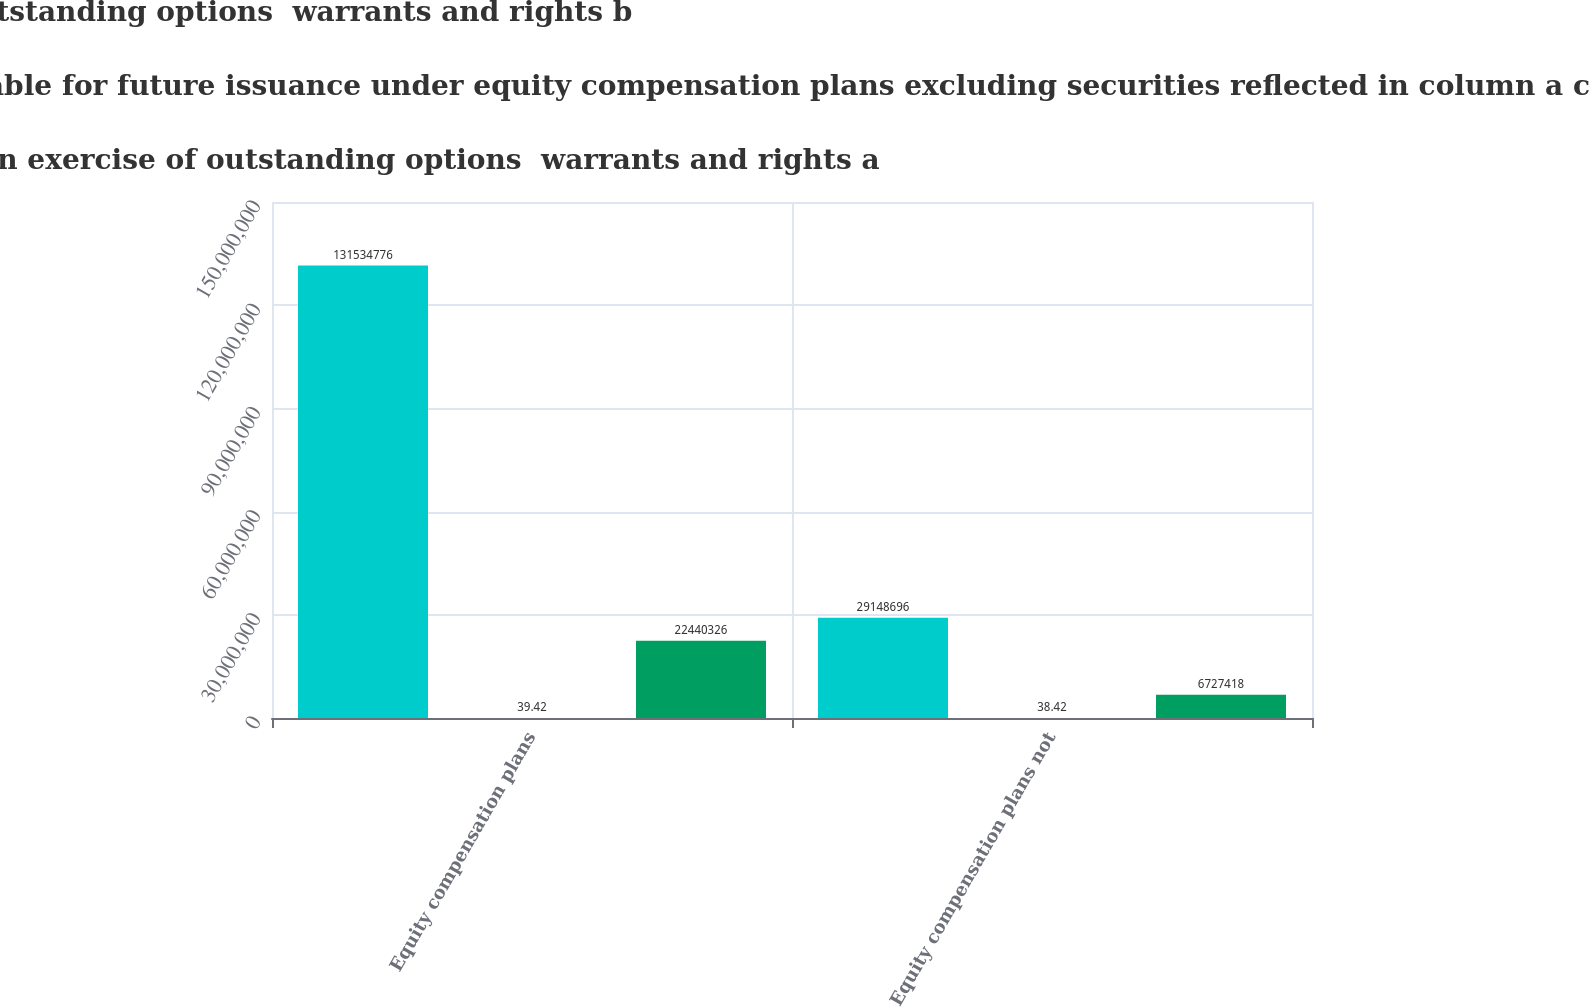<chart> <loc_0><loc_0><loc_500><loc_500><stacked_bar_chart><ecel><fcel>Equity compensation plans<fcel>Equity compensation plans not<nl><fcel>Weighted average exercise price of outstanding options  warrants and rights b<fcel>1.31535e+08<fcel>2.91487e+07<nl><fcel>Number of securities remaining available for future issuance under equity compensation plans excluding securities reflected in column a c<fcel>39.42<fcel>38.42<nl><fcel>Number of securities to be issued upon exercise of outstanding options  warrants and rights a<fcel>2.24403e+07<fcel>6.72742e+06<nl></chart> 